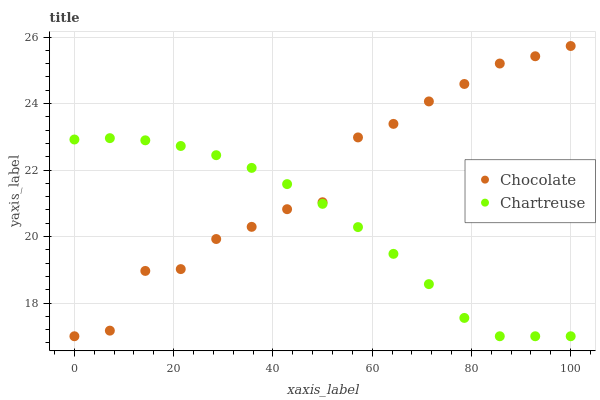Does Chartreuse have the minimum area under the curve?
Answer yes or no. Yes. Does Chocolate have the maximum area under the curve?
Answer yes or no. Yes. Does Chocolate have the minimum area under the curve?
Answer yes or no. No. Is Chartreuse the smoothest?
Answer yes or no. Yes. Is Chocolate the roughest?
Answer yes or no. Yes. Is Chocolate the smoothest?
Answer yes or no. No. Does Chartreuse have the lowest value?
Answer yes or no. Yes. Does Chocolate have the highest value?
Answer yes or no. Yes. Does Chocolate intersect Chartreuse?
Answer yes or no. Yes. Is Chocolate less than Chartreuse?
Answer yes or no. No. Is Chocolate greater than Chartreuse?
Answer yes or no. No. 